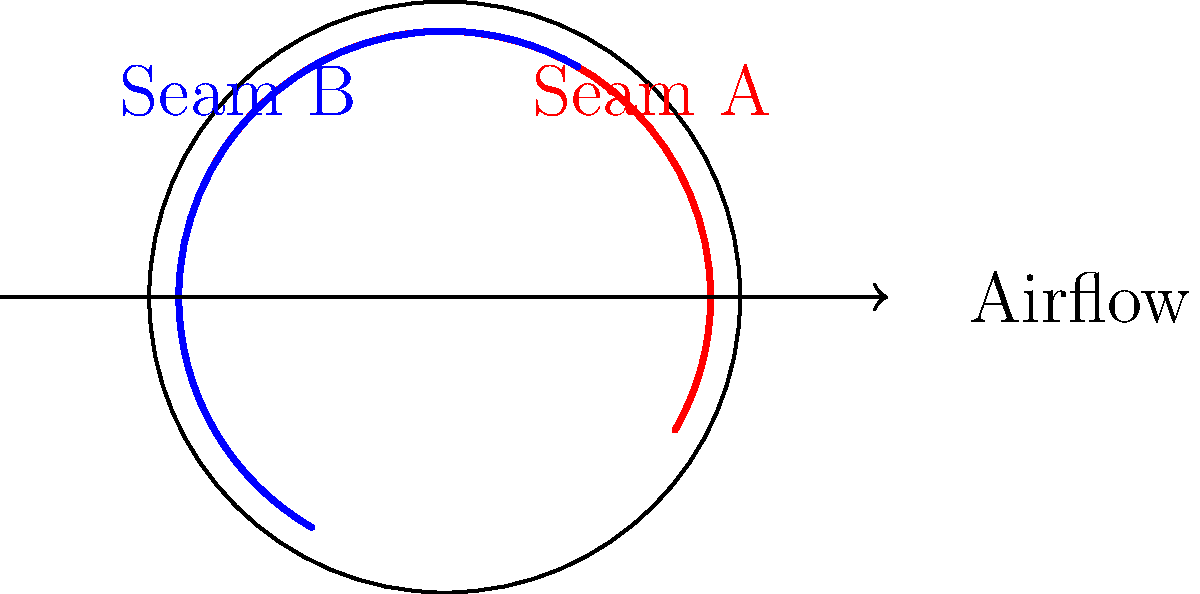In cricket, the orientation of the ball's seam can significantly affect its aerodynamics. Consider the diagram showing two different seam orientations (A and B) of a cricket ball in flight. Which seam orientation is more likely to generate side force, causing the ball to swing in the air? To understand which seam orientation is more likely to generate side force, we need to consider the principles of aerodynamics and the Magnus effect:

1. Seam orientation affects the airflow around the ball:
   - Seam A (red) is angled to the airflow
   - Seam B (blue) is parallel to the airflow

2. The angled seam (Seam A) creates an asymmetric airflow:
   - One side of the ball experiences smoother airflow
   - The other side experiences more turbulent airflow

3. This asymmetry in airflow leads to a pressure difference:
   - Lower pressure on the smoother side
   - Higher pressure on the turbulent side

4. The pressure difference results in a side force (Magnus effect):
   - The ball tends to move towards the lower pressure side

5. Seam B, being parallel to the airflow, does not create significant asymmetry:
   - Airflow is more symmetrical on both sides
   - Less likely to generate a substantial side force

6. Therefore, Seam A orientation is more likely to generate side force and cause the ball to swing in the air.

This phenomenon is crucial in cricket, as bowlers use it to their advantage by strategically positioning the seam to make the ball swing and deceive the batsman.
Answer: Seam A (angled to airflow) 